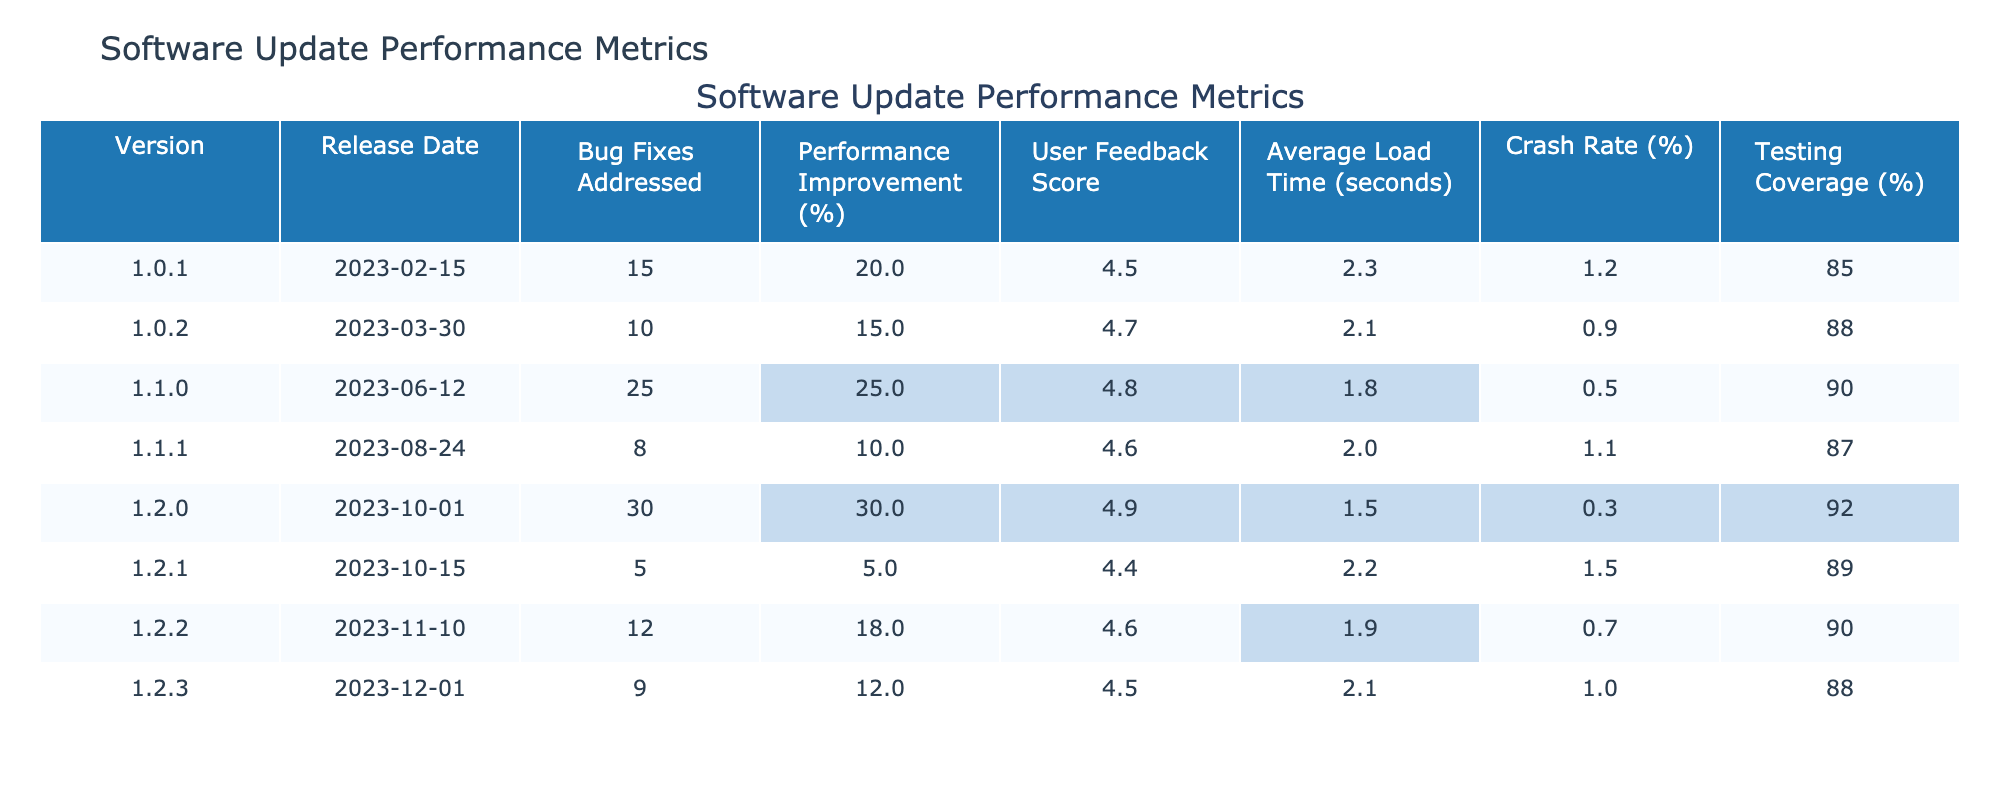What is the User Feedback Score for version 1.2.0? From the table, I can see that for version 1.2.0, the User Feedback Score is listed as 4.9.
Answer: 4.9 Which version had the highest Performance Improvement percentage? Looking at the Performance Improvement column, the highest value is 30% for version 1.2.0.
Answer: 1.2.0 What is the difference in Average Load Time between version 1.1.0 and version 1.2.0? For version 1.1.0, the Average Load Time is 1.8 seconds, and for version 1.2.0, it is 1.5 seconds. The difference is 1.8 - 1.5 = 0.3 seconds.
Answer: 0.3 seconds Is the Crash Rate for version 1.0.2 less than 1%? The Crash Rate for version 1.0.2 is 0.9%, which is indeed less than 1%.
Answer: Yes Which version has the lowest Crash Rate and what is that rate? Scanning through the Crash Rate column, version 1.2.0 has the lowest rate at 0.3%.
Answer: 0.3% What is the average Performance Improvement percentage of the versions that have a User Feedback Score above 4.6? First, identify the versions with User Feedback Scores above 4.6: they are 1.0.2 (15%), 1.1.0 (25%), 1.2.0 (30%), and 1.2.2 (18%). Then, sum these values: 15 + 25 + 30 + 18 = 88%. Divide by 4 (the number of versions) gives an average of 22%.
Answer: 22% How many Bug Fixes were addressed in the most recent update? Checking the Bug Fixes Addressed column for the most recent release date, which is for 1.2.2, I see that 12 Bug Fixes were addressed.
Answer: 12 Which version had the highest Testing Coverage and what was that percentage? Looking at the Testing Coverage column, I see that version 1.2.0 has the highest Testing Coverage at 92%.
Answer: 92% Is there any version that has a Performance Improvement percentage of less than 10%? By reviewing the Performance Improvement percentages, there are no versions with a percentage less than 10%. The lowest is 5% for version 1.2.1.
Answer: No What is the total number of Bug Fixes Addressed across versions 1.0.1 and 1.1.1? Adding the Bug Fixes Addressed for the two versions, 15 (1.0.1) + 8 (1.1.1) = 23 Bug Fixes in total.
Answer: 23 